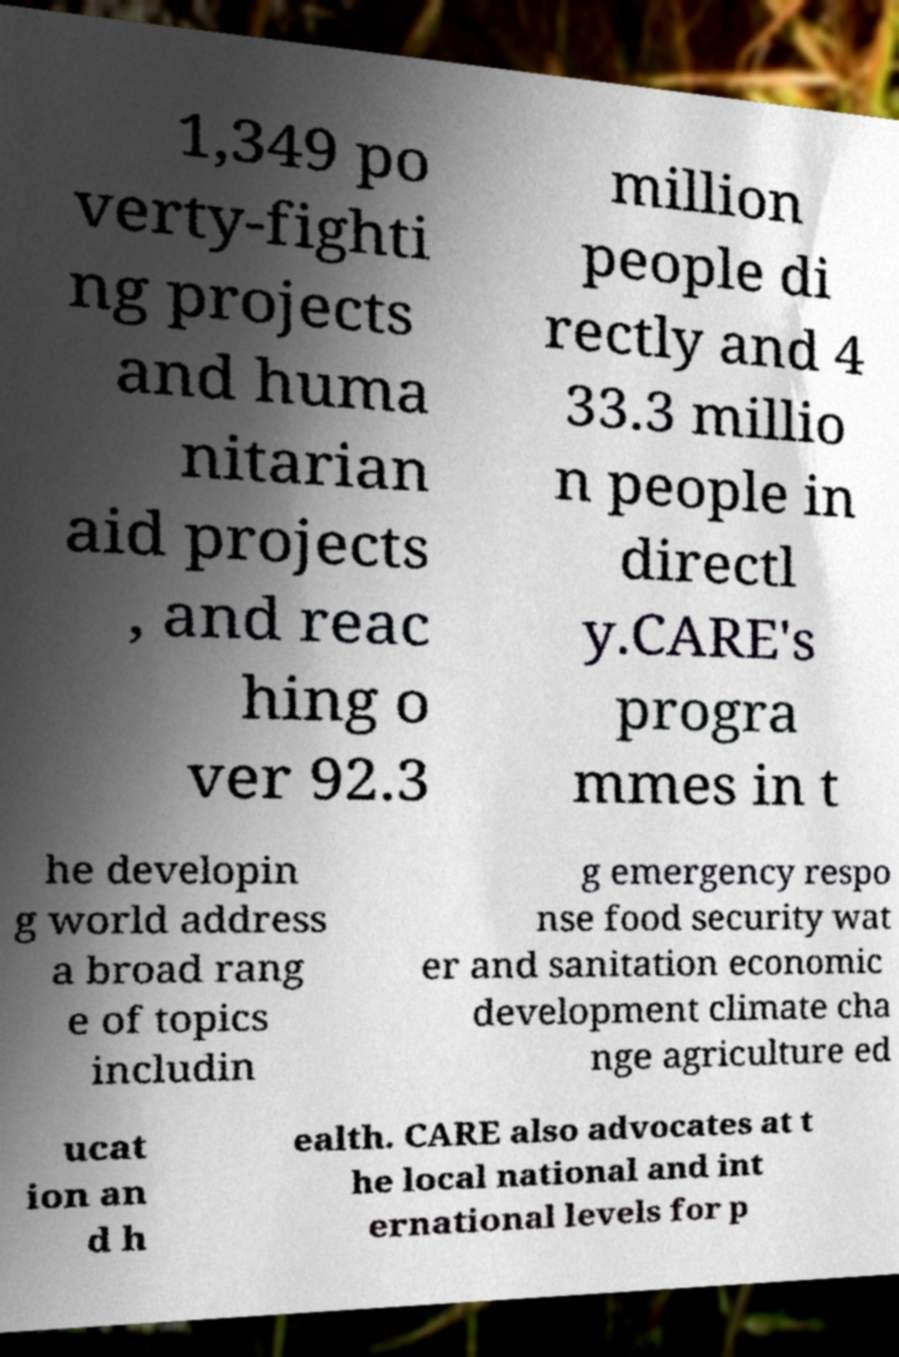There's text embedded in this image that I need extracted. Can you transcribe it verbatim? 1,349 po verty-fighti ng projects and huma nitarian aid projects , and reac hing o ver 92.3 million people di rectly and 4 33.3 millio n people in directl y.CARE's progra mmes in t he developin g world address a broad rang e of topics includin g emergency respo nse food security wat er and sanitation economic development climate cha nge agriculture ed ucat ion an d h ealth. CARE also advocates at t he local national and int ernational levels for p 